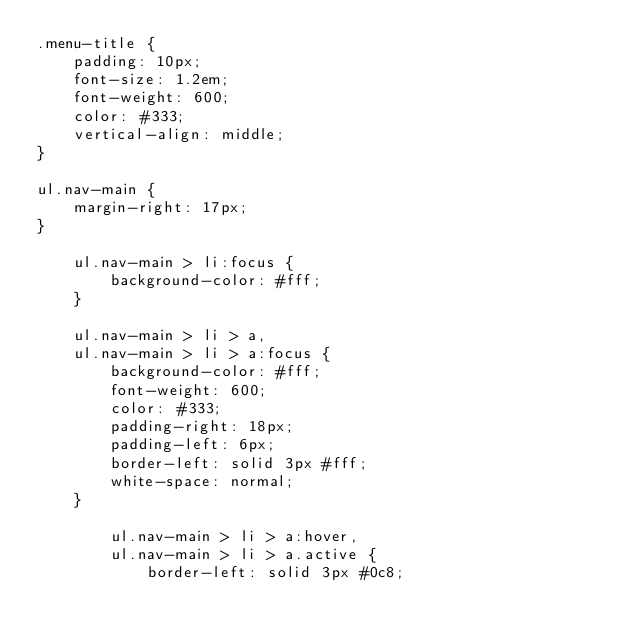Convert code to text. <code><loc_0><loc_0><loc_500><loc_500><_CSS_>.menu-title {
    padding: 10px;
    font-size: 1.2em;
    font-weight: 600;
    color: #333;
    vertical-align: middle;
}

ul.nav-main {
    margin-right: 17px;
}

    ul.nav-main > li:focus {
        background-color: #fff;
    }

    ul.nav-main > li > a,
    ul.nav-main > li > a:focus {
        background-color: #fff;
        font-weight: 600;
        color: #333;
        padding-right: 18px;
        padding-left: 6px;
        border-left: solid 3px #fff;
        white-space: normal;
    }

        ul.nav-main > li > a:hover,
        ul.nav-main > li > a.active {
            border-left: solid 3px #0c8;</code> 